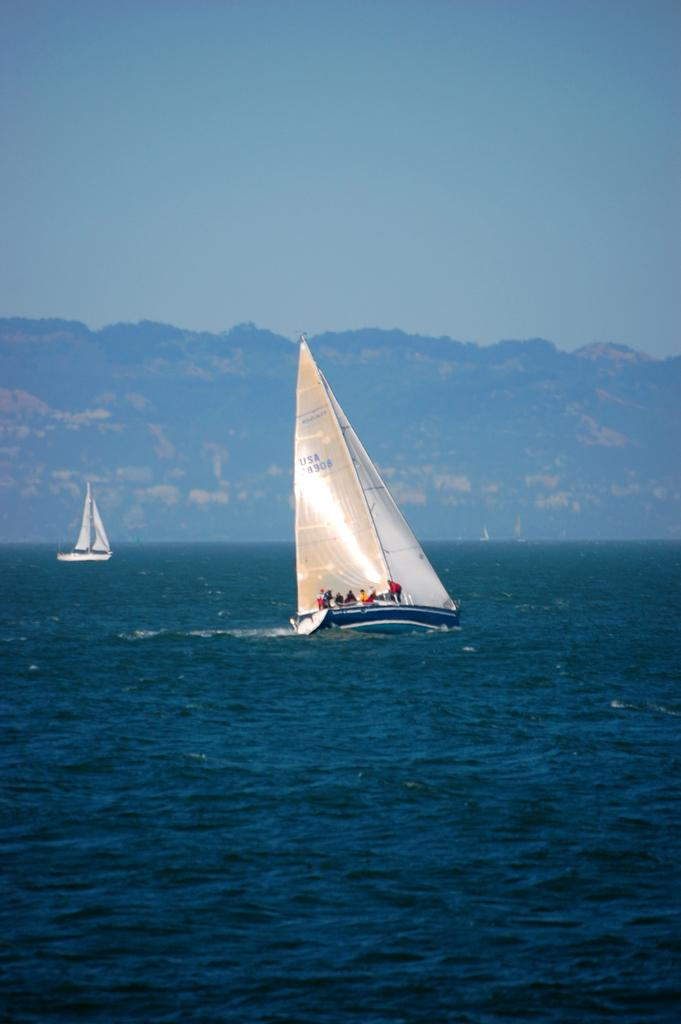What can be seen in the image? There are two ships in the image. Where are the ships located? The ships are sailing on the sea. What can be seen in the distance in the image? There is a mountain visible in the background of the image. What type of payment is being made on the ships in the image? There is no indication of any payment being made in the image; it simply shows two ships sailing on the sea. 